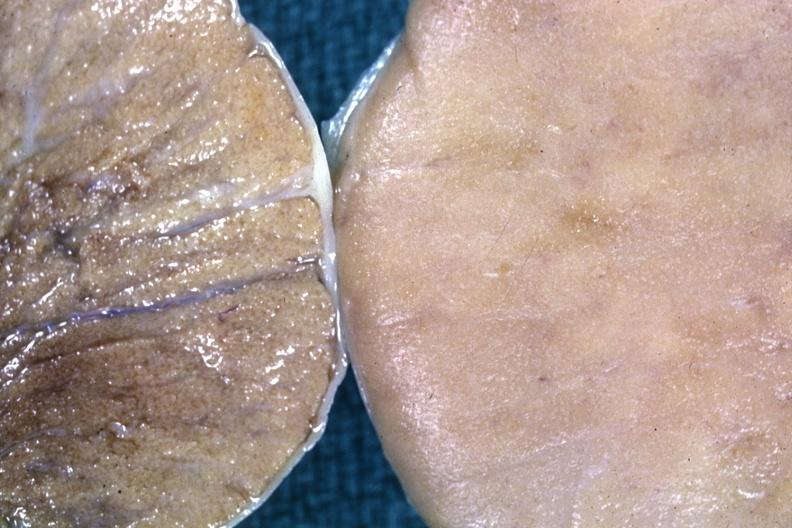what is present?
Answer the question using a single word or phrase. Testicle 